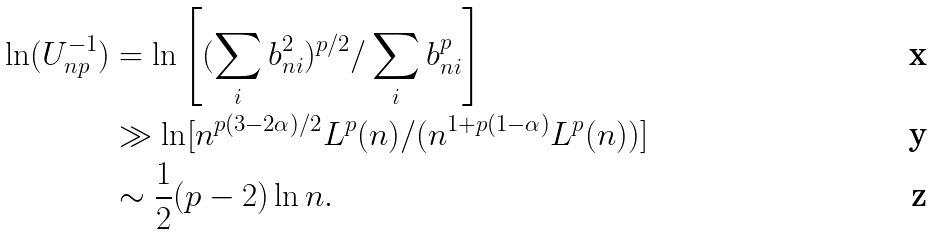Convert formula to latex. <formula><loc_0><loc_0><loc_500><loc_500>\ln ( U _ { n p } ^ { - 1 } ) & = \ln \left [ ( \sum _ { i } b _ { n i } ^ { 2 } ) ^ { p / 2 } / \sum _ { i } b _ { n i } ^ { p } \right ] \\ & \gg \ln [ n ^ { p ( 3 - 2 \alpha ) / 2 } L ^ { p } ( n ) / ( n ^ { 1 + p ( 1 - \alpha ) } L ^ { p } ( n ) ) ] \\ & \sim \frac { 1 } { 2 } ( p - 2 ) \ln n .</formula> 